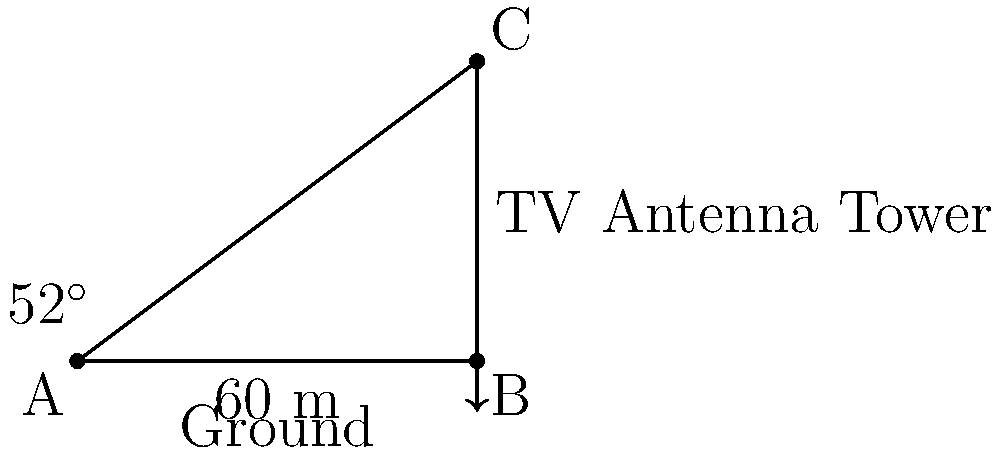As a dedicated fan of your favorite TV show, you're curious about the height of the antenna tower that broadcasts the signal. Standing 60 meters away from the base of the tower, you measure the angle of elevation to the top of the tower to be 52°. Using this information, calculate the height of the TV antenna tower to the nearest meter. Let's approach this step-by-step:

1) We can model this situation as a right-angled triangle, where:
   - The base of the triangle is the distance from you to the tower (60 m)
   - The height of the triangle is the height of the tower (what we're trying to find)
   - The angle at the base is the angle of elevation (52°)

2) In this right-angled triangle, we know:
   - The adjacent side (distance to the tower) = 60 m
   - The angle = 52°
   - We need to find the opposite side (height of the tower)

3) This is a perfect scenario to use the tangent trigonometric function:

   $\tan(\theta) = \frac{\text{opposite}}{\text{adjacent}}$

4) Plugging in our known values:

   $\tan(52°) = \frac{\text{height}}{60}$

5) To solve for the height, we multiply both sides by 60:

   $60 \cdot \tan(52°) = \text{height}$

6) Using a calculator (or trigonometric tables):

   $60 \cdot \tan(52°) \approx 60 \cdot 1.2799 \approx 76.794$ meters

7) Rounding to the nearest meter as requested:

   Height ≈ 77 meters

Therefore, the TV antenna tower is approximately 77 meters tall.
Answer: 77 meters 